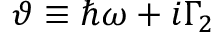Convert formula to latex. <formula><loc_0><loc_0><loc_500><loc_500>\vartheta \equiv \hbar { \omega } + i \Gamma _ { 2 }</formula> 